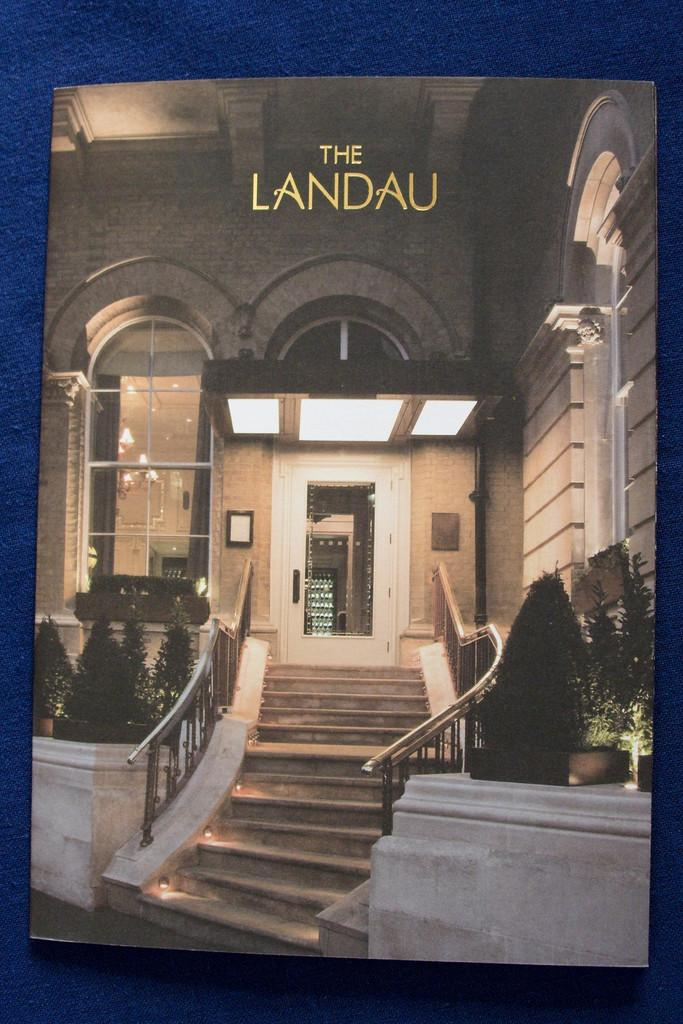Provide a one-sentence caption for the provided image. Stairs lead to the entry door of The Landau. 